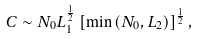<formula> <loc_0><loc_0><loc_500><loc_500>C \sim N _ { 0 } L _ { 1 } ^ { \frac { 1 } { 2 } } \left [ \min \left ( N _ { 0 } , L _ { 2 } \right ) \right ] ^ { \frac { 1 } { 2 } } ,</formula> 